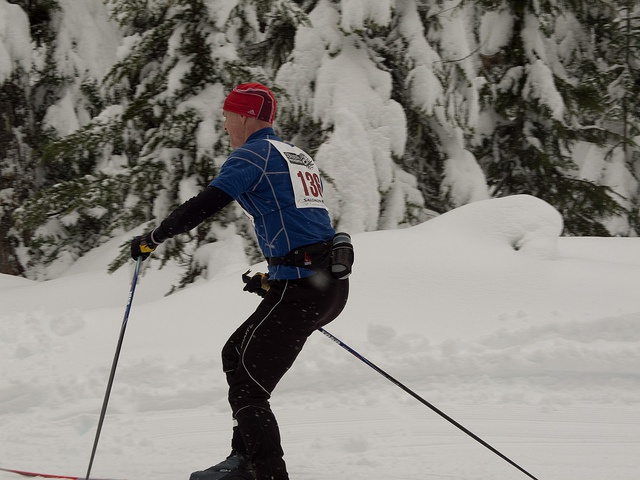Describe the objects in this image and their specific colors. I can see people in darkgray, black, navy, gray, and maroon tones, skis in darkgray, brown, and gray tones, and bottle in darkgray, gray, black, and purple tones in this image. 